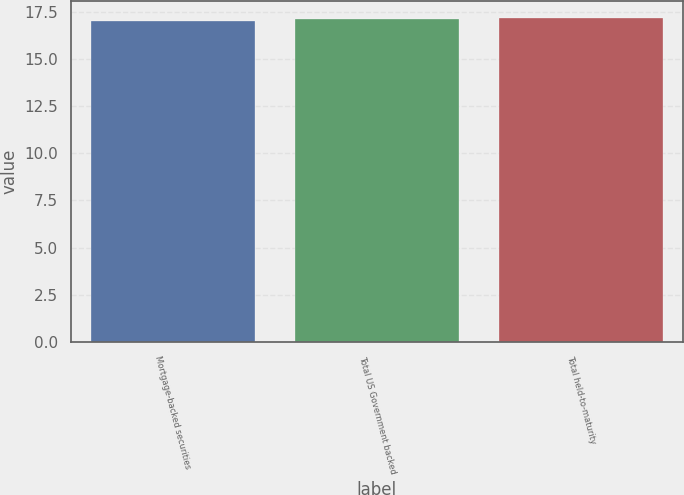<chart> <loc_0><loc_0><loc_500><loc_500><bar_chart><fcel>Mortgage-backed securities<fcel>Total US Government backed<fcel>Total held-to-maturity<nl><fcel>17<fcel>17.1<fcel>17.2<nl></chart> 